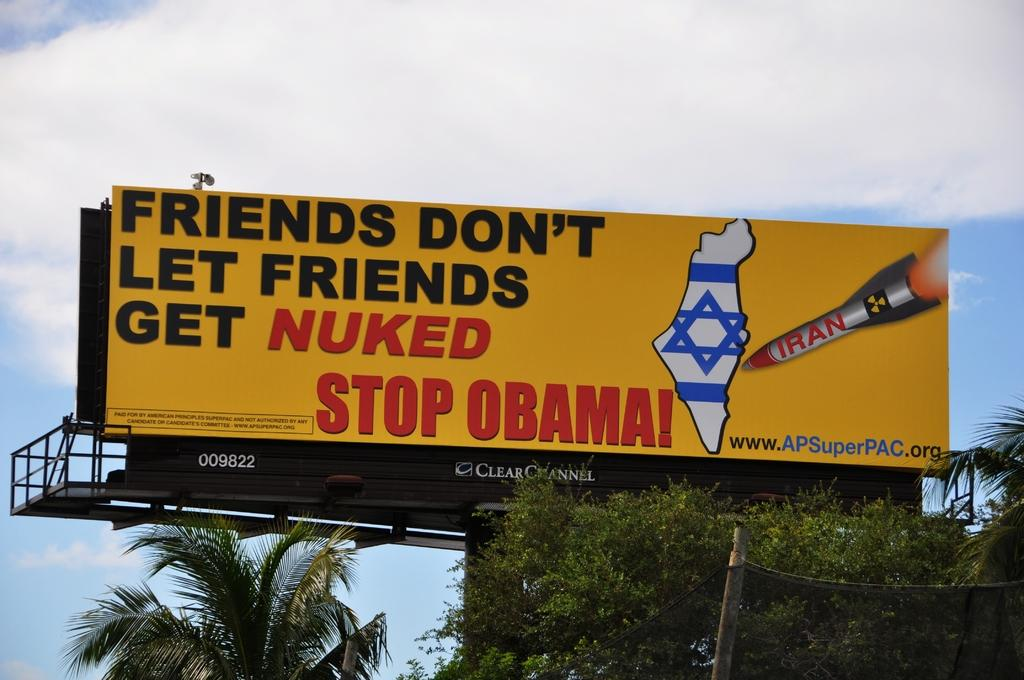Provide a one-sentence caption for the provided image. A large freeway billboard that says Friends Don't let friends get nuked stop obama. 